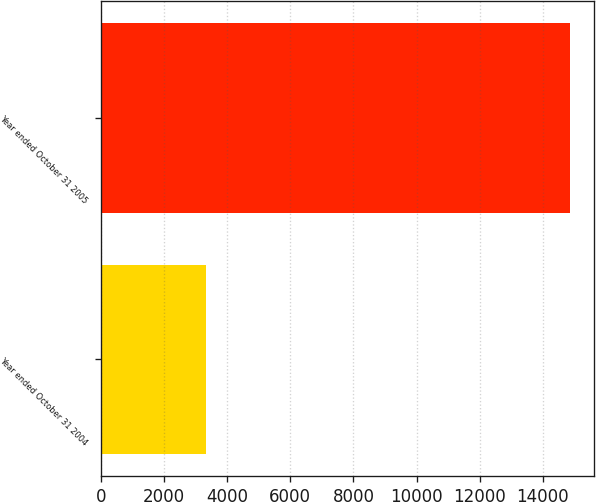<chart> <loc_0><loc_0><loc_500><loc_500><bar_chart><fcel>Year ended October 31 2004<fcel>Year ended October 31 2005<nl><fcel>3331<fcel>14860<nl></chart> 